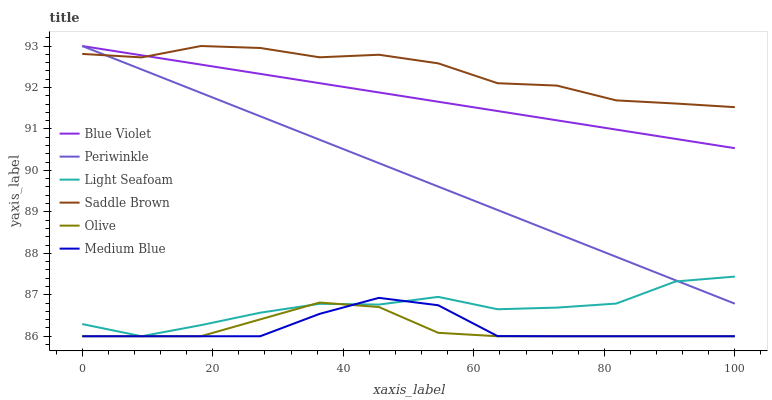Does Olive have the minimum area under the curve?
Answer yes or no. Yes. Does Saddle Brown have the maximum area under the curve?
Answer yes or no. Yes. Does Periwinkle have the minimum area under the curve?
Answer yes or no. No. Does Periwinkle have the maximum area under the curve?
Answer yes or no. No. Is Blue Violet the smoothest?
Answer yes or no. Yes. Is Light Seafoam the roughest?
Answer yes or no. Yes. Is Periwinkle the smoothest?
Answer yes or no. No. Is Periwinkle the roughest?
Answer yes or no. No. Does Periwinkle have the lowest value?
Answer yes or no. No. Does Blue Violet have the highest value?
Answer yes or no. Yes. Does Olive have the highest value?
Answer yes or no. No. Is Olive less than Saddle Brown?
Answer yes or no. Yes. Is Saddle Brown greater than Light Seafoam?
Answer yes or no. Yes. Does Medium Blue intersect Light Seafoam?
Answer yes or no. Yes. Is Medium Blue less than Light Seafoam?
Answer yes or no. No. Is Medium Blue greater than Light Seafoam?
Answer yes or no. No. Does Olive intersect Saddle Brown?
Answer yes or no. No. 